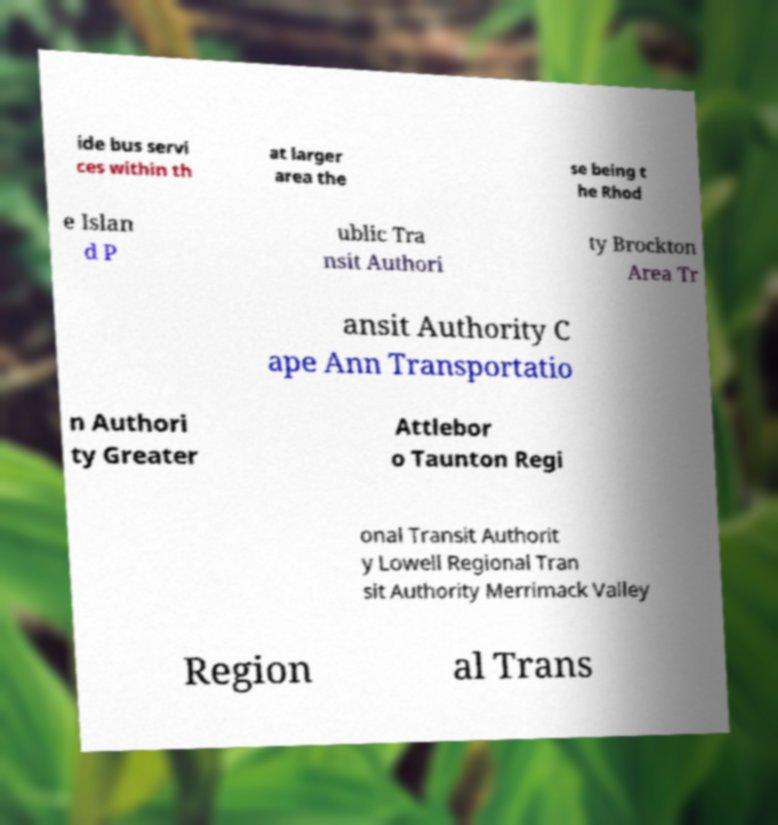For documentation purposes, I need the text within this image transcribed. Could you provide that? ide bus servi ces within th at larger area the se being t he Rhod e Islan d P ublic Tra nsit Authori ty Brockton Area Tr ansit Authority C ape Ann Transportatio n Authori ty Greater Attlebor o Taunton Regi onal Transit Authorit y Lowell Regional Tran sit Authority Merrimack Valley Region al Trans 